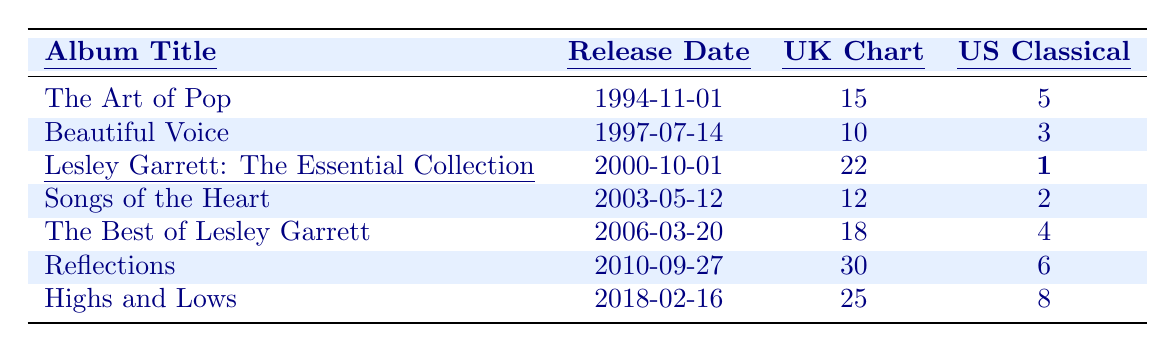What is the release date of "Beautiful Voice"? Looking at the table, the release date for "Beautiful Voice" is listed under the Release Date column next to the album title. It shows 1997-07-14.
Answer: 1997-07-14 Which album had the highest position on the US Classical Albums chart? By reviewing the US Classical Albums column, I see that "Lesley Garrett: The Essential Collection" is marked with the highest chart position of 1.
Answer: Lesley Garrett: The Essential Collection What was the UK Albums Chart position of "Songs of the Heart"? The table shows "Songs of the Heart" in the UK Albums Chart column, which indicates it reached position 12.
Answer: 12 How many albums were released before the year 2000? Counting the albums, the ones released before 2000 are "The Art of Pop," "Beautiful Voice," and "Lesley Garrett: The Essential Collection," totaling three albums.
Answer: 3 Did "Reflections" perform better in the UK or the US Classical charts? The UK Albums Chart position for "Reflections" is 30, while its US Classical position is 6. Since 6 is a better position than 30, it performed better in the US.
Answer: Yes, better in the US What is the average chart position for the albums in the UK Albums Chart? The UK chart positions are 15, 10, 22, 12, 18, 30, and 25. Adding these gives 15 + 10 + 22 + 12 + 18 + 30 + 25 = 132. There are 7 albums, so the average is 132/7 ≈ 18.86.
Answer: Approximately 18.86 Which album was released in 2018, and what was its US Classical Albums chart position? The table indicates "Highs and Lows" is the album released in 2018, which shows a chart position of 8 in the US Classical Albums.
Answer: Highs and Lows; 8 Is there any album released after 2010 that reached a higher UK Albums Chart position than "Reflections"? "Reflections" has a chart position of 30, and the album released after 2010 is "Highs and Lows," which reached position 25. Since 25 < 30, no album reached a higher position.
Answer: No What is the difference between the UK and US Classical chart positions for "The Best of Lesley Garrett"? "The Best of Lesley Garrett" has a UK position of 18 and a US position of 4. The difference is 18 - 4 = 14.
Answer: 14 Which album has the lowest peak position on the UK Albums Chart? The table shows "Reflections" with the highest position of 30, which is lower compared to other albums listed.
Answer: Reflections 